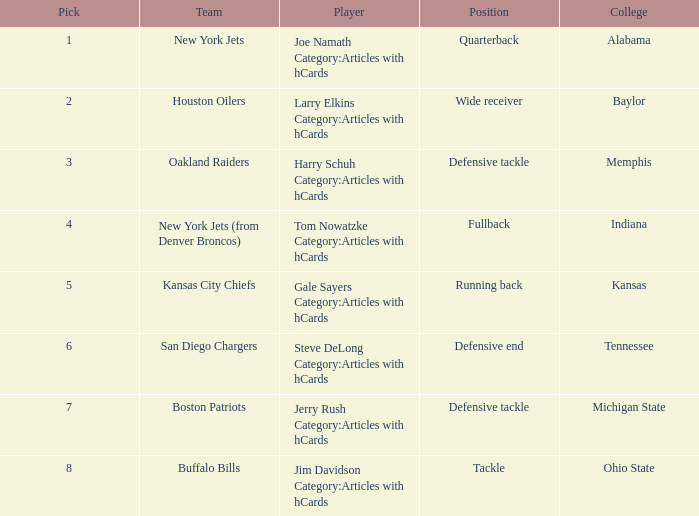What is the paramount pick for the defensive end position? 6.0. 